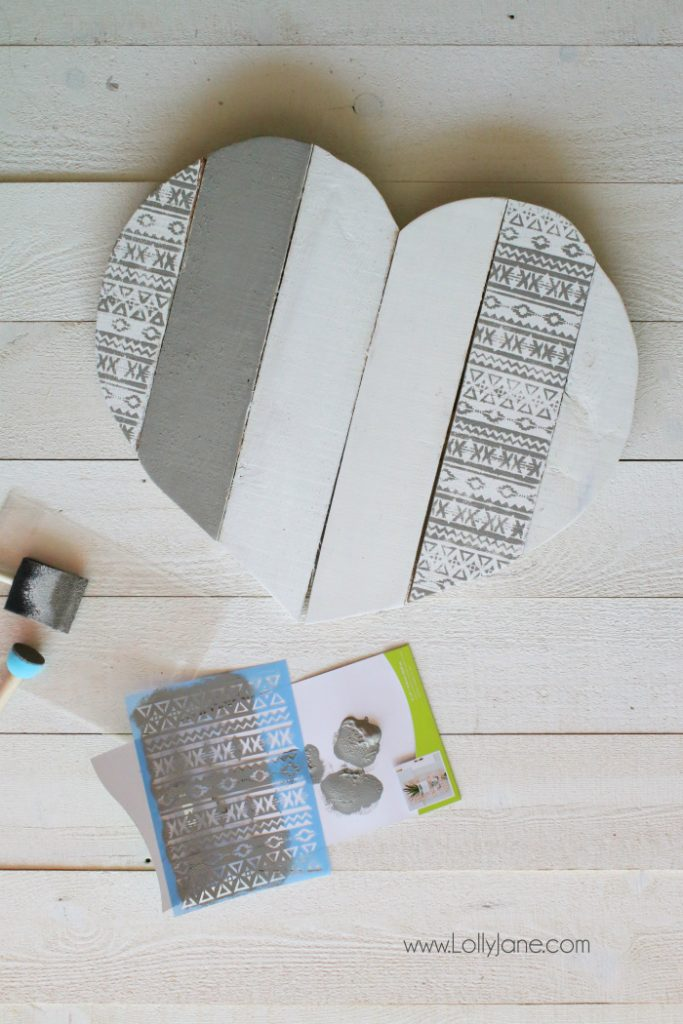What are some creative ways to incorporate this wooden heart into home decor? This wooden heart could be a versatile addition to home decor. Some creative ways to incorporate it include: hanging it as a statement piece on a gallery wall, using it as a unique centerpiece for a coffee table or mantel, mounting it on the front door as a seasonal decoration, incorporating it into a photo backdrop for special events, or even using it as a decorative tray. Additionally, it could be personalized with initials, quotes, or names for a more customized touch. The possibilities are endless, providing a charming and personal element to any home decor arrangement. Can you imagine a story behind this wooden heart? Perhaps it was a gift for a special occasion. Certainly! Imagine this wooden heart was crafted with love and care by an artisan named Emma. She created it as a heartfelt anniversary gift for her grandparents' 50th wedding anniversary. Knowing their lifelong love for traditional patterns and handcrafted items, she carefully selected the stencil design, reminiscent of the vintage textiles from their youth. As Emma painted, she thought of the many stories her grandparents shared about their adventures and life together. On the day of their anniversary celebration, Emma presented them with the wooden heart as a symbol of their enduring love and the beautiful memories they created together. The heart now hangs in their living room, a daily reminder of their bond and the heartfelt gift from their beloved granddaughter. Imagine if this wooden heart held a secret compartment. What might someone hide inside, and why? If the wooden heart held a secret compartment, it might be the perfect place to hide small but precious keepsakes, such as love letters, a treasured locket, or a cherished photograph. Someone might choose to hide these items in the heart because it's a symbol of personal and intimate emotions. The hidden compartment would provide a safe and special place to keep these dear objects close at hand, while also maintaining their secrecy and protecting them from being lost or damaged. In a more whimsical scenario, the secret compartment could even hold the key to a hidden garden, an heirloom ring meant for a future proposal, or a map leading to a family treasure, adding an element of mystery and wonder to the otherwise serene piece of art. 